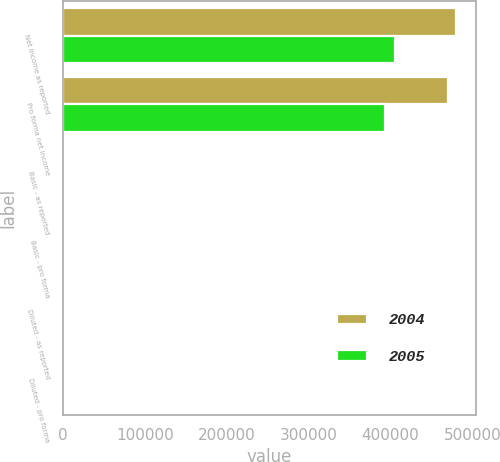Convert chart. <chart><loc_0><loc_0><loc_500><loc_500><stacked_bar_chart><ecel><fcel>Net income as reported<fcel>Pro forma net income<fcel>Basic - as reported<fcel>Basic - pro forma<fcel>Diluted - as reported<fcel>Diluted - pro forma<nl><fcel>2004<fcel>480121<fcel>470328<fcel>5.27<fcel>5.16<fcel>5.16<fcel>5.08<nl><fcel>2005<fcel>405987<fcel>393484<fcel>4.53<fcel>4.39<fcel>4.47<fcel>4.33<nl></chart> 